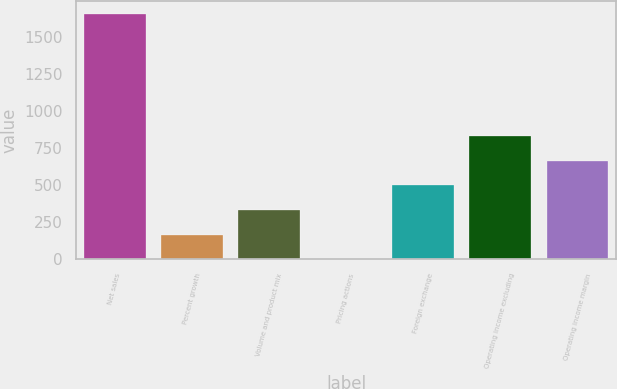<chart> <loc_0><loc_0><loc_500><loc_500><bar_chart><fcel>Net sales<fcel>Percent growth<fcel>Volume and product mix<fcel>Pricing actions<fcel>Foreign exchange<fcel>Operating income excluding<fcel>Operating income margin<nl><fcel>1661.1<fcel>168.45<fcel>334.3<fcel>2.6<fcel>500.15<fcel>831.85<fcel>666<nl></chart> 